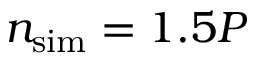<formula> <loc_0><loc_0><loc_500><loc_500>{ { n _ { s i m } } } = 1 . 5 P</formula> 